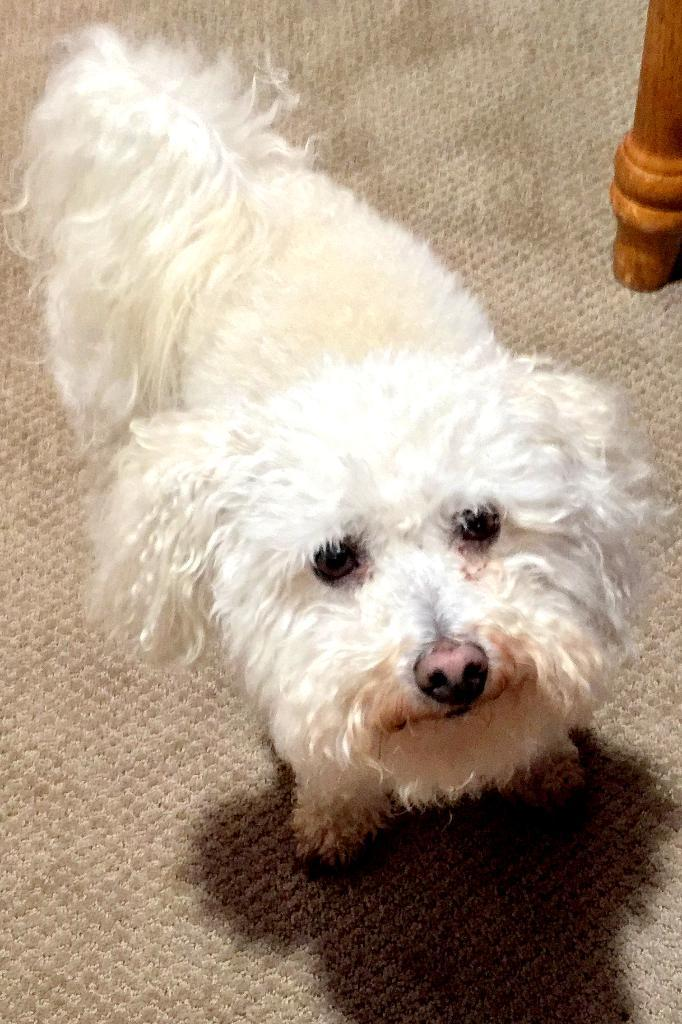What is located in the center of the image? There is a carpet in the center of the image. What is on the carpet? There is a dog on the carpet. What color is the dog? The dog is white in color. What type of object can be seen in the top right side of the image? There is a wooden object in the top right side of the image. What type of crack can be seen in the image? There is no crack present in the image. What observation can be made about the dog's behavior in the image? The image does not show the dog's behavior, only its position on the carpet. 